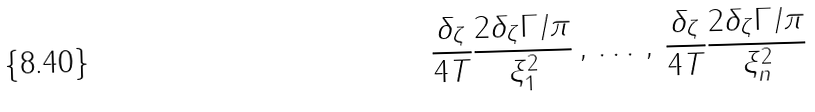Convert formula to latex. <formula><loc_0><loc_0><loc_500><loc_500>\frac { \delta _ { \zeta } } { 4 T } \frac { 2 \delta _ { \zeta } \Gamma / \pi } { \xi _ { 1 } ^ { 2 } } \, , \, \dots \, , \, \frac { \delta _ { \zeta } } { 4 T } \frac { 2 \delta _ { \zeta } \Gamma / \pi } { \xi _ { n } ^ { 2 } }</formula> 